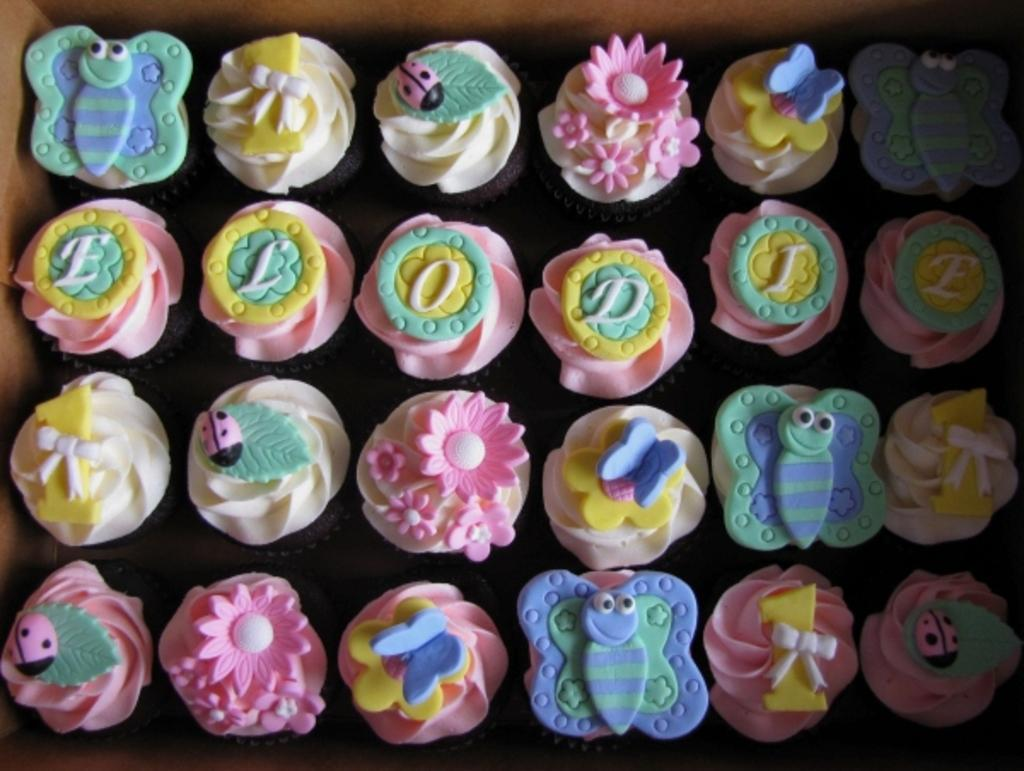What type of baked goods can be seen in the image? There are cupcakes in the image. How are the cupcakes being stored or transported? The cupcakes are in a cardboard box. What colors are the cupcakes in the image? The cupcakes are in multi-color. What type of butter is used to make the cupcakes in the image? There is no information about the type of butter used to make the cupcakes in the image. How many oranges are visible in the image? There are no oranges present in the image. 